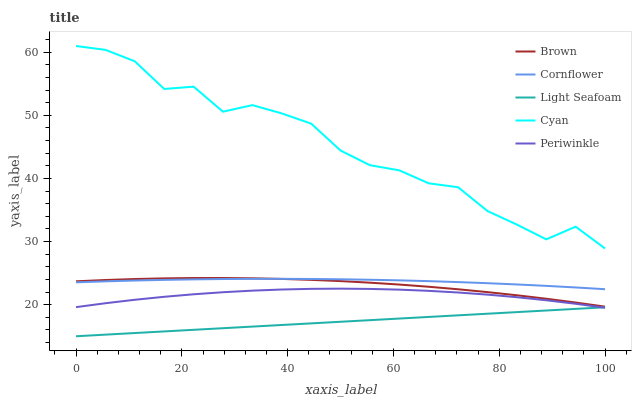Does Light Seafoam have the minimum area under the curve?
Answer yes or no. Yes. Does Cyan have the maximum area under the curve?
Answer yes or no. Yes. Does Cyan have the minimum area under the curve?
Answer yes or no. No. Does Light Seafoam have the maximum area under the curve?
Answer yes or no. No. Is Light Seafoam the smoothest?
Answer yes or no. Yes. Is Cyan the roughest?
Answer yes or no. Yes. Is Cyan the smoothest?
Answer yes or no. No. Is Light Seafoam the roughest?
Answer yes or no. No. Does Light Seafoam have the lowest value?
Answer yes or no. Yes. Does Cyan have the lowest value?
Answer yes or no. No. Does Cyan have the highest value?
Answer yes or no. Yes. Does Light Seafoam have the highest value?
Answer yes or no. No. Is Brown less than Cyan?
Answer yes or no. Yes. Is Cyan greater than Cornflower?
Answer yes or no. Yes. Does Light Seafoam intersect Periwinkle?
Answer yes or no. Yes. Is Light Seafoam less than Periwinkle?
Answer yes or no. No. Is Light Seafoam greater than Periwinkle?
Answer yes or no. No. Does Brown intersect Cyan?
Answer yes or no. No. 